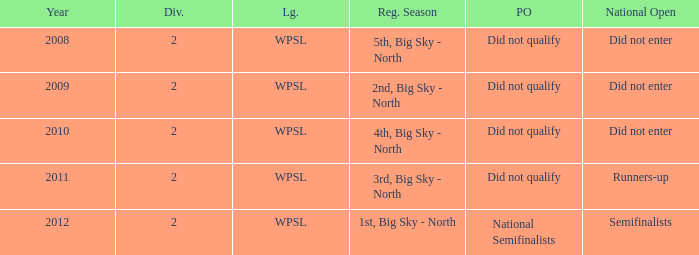What league was involved in 2008? WPSL. 